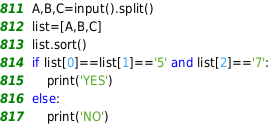Convert code to text. <code><loc_0><loc_0><loc_500><loc_500><_Python_>A,B,C=input().split()
list=[A,B,C]
list.sort()
if list[0]==list[1]=='5' and list[2]=='7':
    print('YES')
else:
    print('NO')</code> 